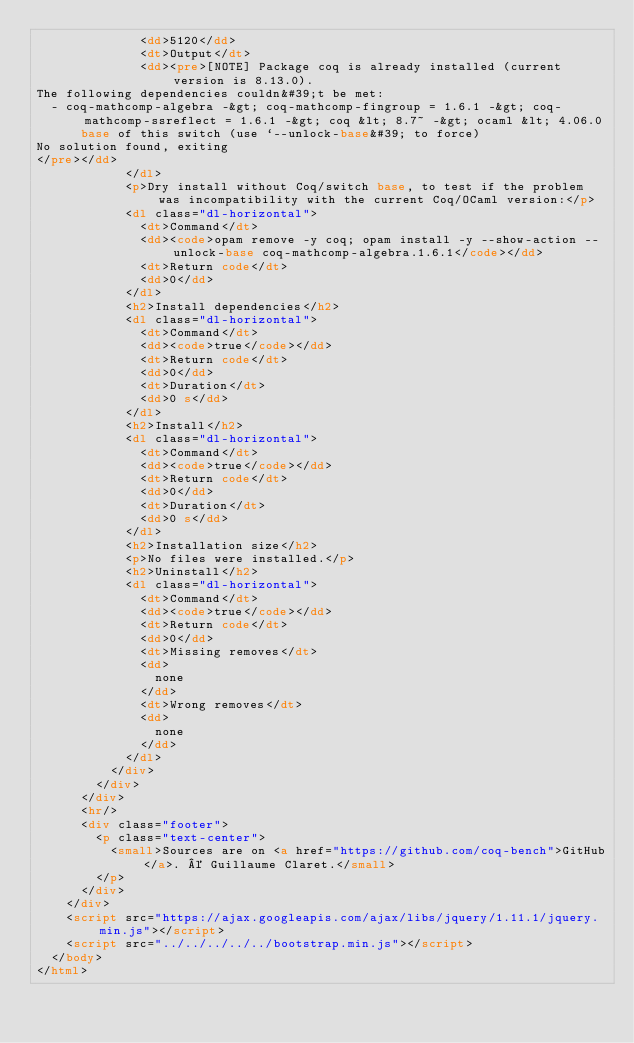<code> <loc_0><loc_0><loc_500><loc_500><_HTML_>              <dd>5120</dd>
              <dt>Output</dt>
              <dd><pre>[NOTE] Package coq is already installed (current version is 8.13.0).
The following dependencies couldn&#39;t be met:
  - coq-mathcomp-algebra -&gt; coq-mathcomp-fingroup = 1.6.1 -&gt; coq-mathcomp-ssreflect = 1.6.1 -&gt; coq &lt; 8.7~ -&gt; ocaml &lt; 4.06.0
      base of this switch (use `--unlock-base&#39; to force)
No solution found, exiting
</pre></dd>
            </dl>
            <p>Dry install without Coq/switch base, to test if the problem was incompatibility with the current Coq/OCaml version:</p>
            <dl class="dl-horizontal">
              <dt>Command</dt>
              <dd><code>opam remove -y coq; opam install -y --show-action --unlock-base coq-mathcomp-algebra.1.6.1</code></dd>
              <dt>Return code</dt>
              <dd>0</dd>
            </dl>
            <h2>Install dependencies</h2>
            <dl class="dl-horizontal">
              <dt>Command</dt>
              <dd><code>true</code></dd>
              <dt>Return code</dt>
              <dd>0</dd>
              <dt>Duration</dt>
              <dd>0 s</dd>
            </dl>
            <h2>Install</h2>
            <dl class="dl-horizontal">
              <dt>Command</dt>
              <dd><code>true</code></dd>
              <dt>Return code</dt>
              <dd>0</dd>
              <dt>Duration</dt>
              <dd>0 s</dd>
            </dl>
            <h2>Installation size</h2>
            <p>No files were installed.</p>
            <h2>Uninstall</h2>
            <dl class="dl-horizontal">
              <dt>Command</dt>
              <dd><code>true</code></dd>
              <dt>Return code</dt>
              <dd>0</dd>
              <dt>Missing removes</dt>
              <dd>
                none
              </dd>
              <dt>Wrong removes</dt>
              <dd>
                none
              </dd>
            </dl>
          </div>
        </div>
      </div>
      <hr/>
      <div class="footer">
        <p class="text-center">
          <small>Sources are on <a href="https://github.com/coq-bench">GitHub</a>. © Guillaume Claret.</small>
        </p>
      </div>
    </div>
    <script src="https://ajax.googleapis.com/ajax/libs/jquery/1.11.1/jquery.min.js"></script>
    <script src="../../../../../bootstrap.min.js"></script>
  </body>
</html>
</code> 